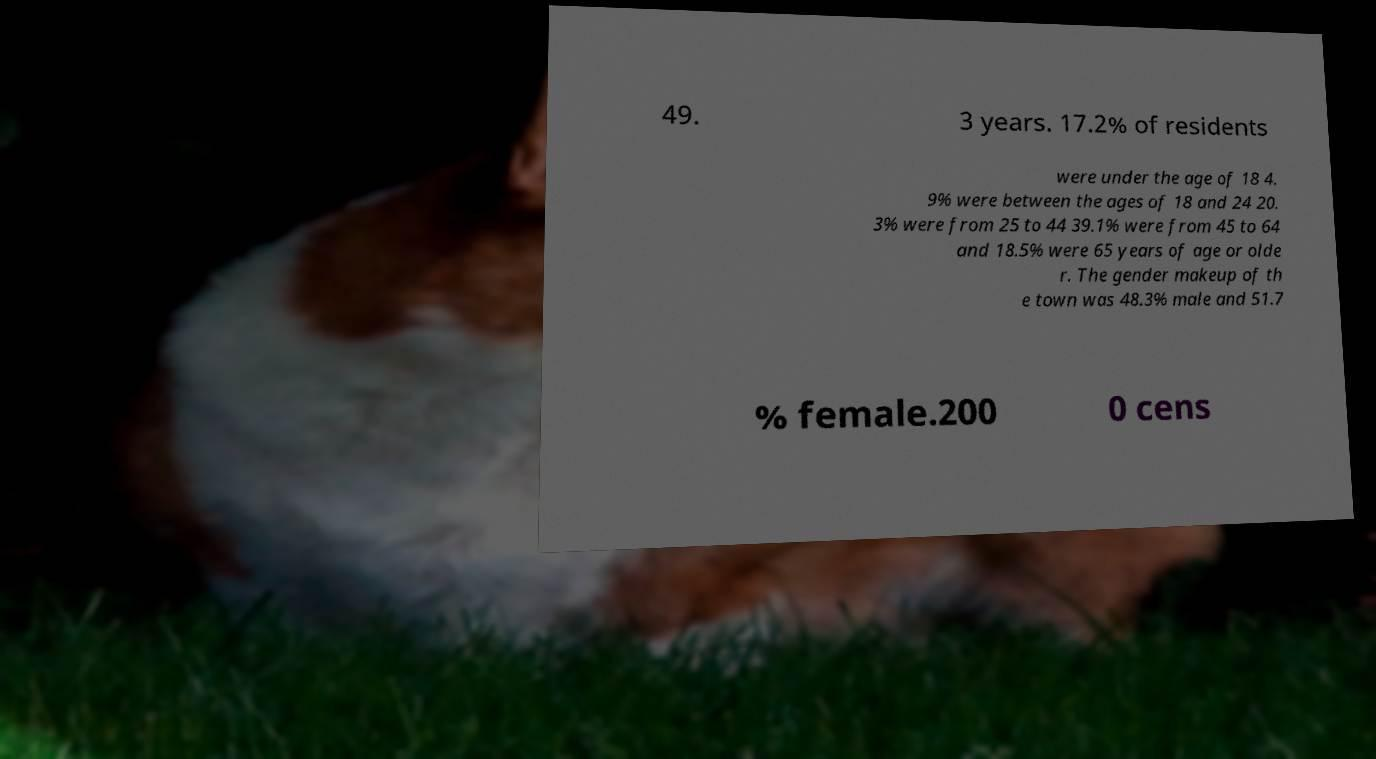What messages or text are displayed in this image? I need them in a readable, typed format. 49. 3 years. 17.2% of residents were under the age of 18 4. 9% were between the ages of 18 and 24 20. 3% were from 25 to 44 39.1% were from 45 to 64 and 18.5% were 65 years of age or olde r. The gender makeup of th e town was 48.3% male and 51.7 % female.200 0 cens 